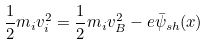<formula> <loc_0><loc_0><loc_500><loc_500>\frac { 1 } { 2 } m _ { i } v _ { i } ^ { 2 } = \frac { 1 } { 2 } m _ { i } v _ { B } ^ { 2 } - e \bar { \psi } _ { s h } ( x )</formula> 